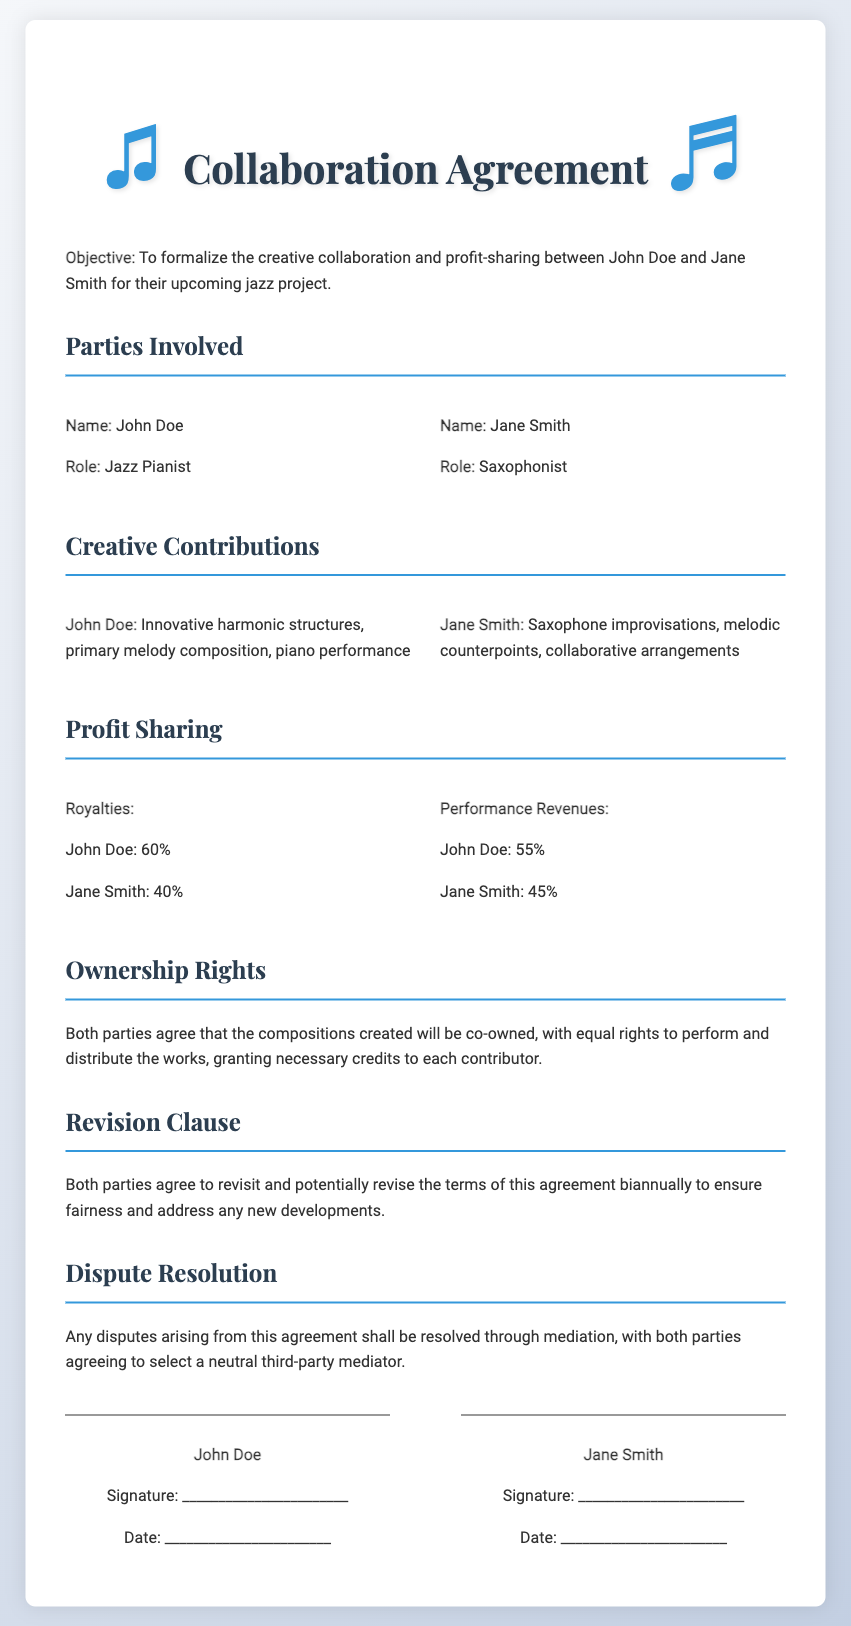What is the name of the jazz pianist? The document states that the jazz pianist's name is John Doe.
Answer: John Doe What percentage of royalties does Jane Smith receive? The document specifies that Jane Smith receives 40% of the royalties.
Answer: 40% What is the purpose of the collaboration agreement? The objective listed in the document highlights the formalization of creative collaboration and profit-sharing for a jazz project.
Answer: To formalize the creative collaboration and profit-sharing What creative contribution does John Doe provide? According to the document, John Doe's contributions include innovative harmonic structures, primary melody composition, and piano performance.
Answer: Innovative harmonic structures, primary melody composition, piano performance What will happen if disputes arise from the agreement? The document specifies that disputes will be resolved through mediation by selecting a neutral third-party mediator.
Answer: Mediation What is the profit share percentage for John Doe from performance revenues? The document indicates that John Doe receives 55% from performance revenues.
Answer: 55% How often will the agreement be revisited? The document states that both parties agree to revisit the terms of the agreement biannually.
Answer: Biannually What rights do both parties have regarding ownership of compositions? The document mentions that both parties agree to co-ownership with equal rights to perform and distribute the works.
Answer: Co-ownership with equal rights 